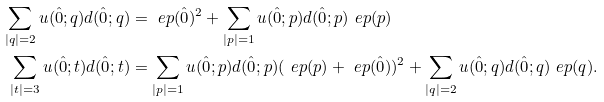Convert formula to latex. <formula><loc_0><loc_0><loc_500><loc_500>\sum _ { | q | = 2 } u ( \hat { 0 } ; q ) d ( \hat { 0 } ; q ) & = \ e p ( \hat { 0 } ) ^ { 2 } + \sum _ { | p | = 1 } u ( \hat { 0 } ; p ) d ( \hat { 0 } ; p ) \ e p ( p ) \\ \sum _ { | t | = 3 } u ( \hat { 0 } ; t ) d ( \hat { 0 } ; t ) & = \sum _ { | p | = 1 } u ( \hat { 0 } ; p ) d ( \hat { 0 } ; p ) ( \ e p ( p ) + \ e p ( \hat { 0 } ) ) ^ { 2 } + \sum _ { | q | = 2 } u ( \hat { 0 } ; q ) d ( \hat { 0 } ; q ) \ e p ( q ) . \\</formula> 